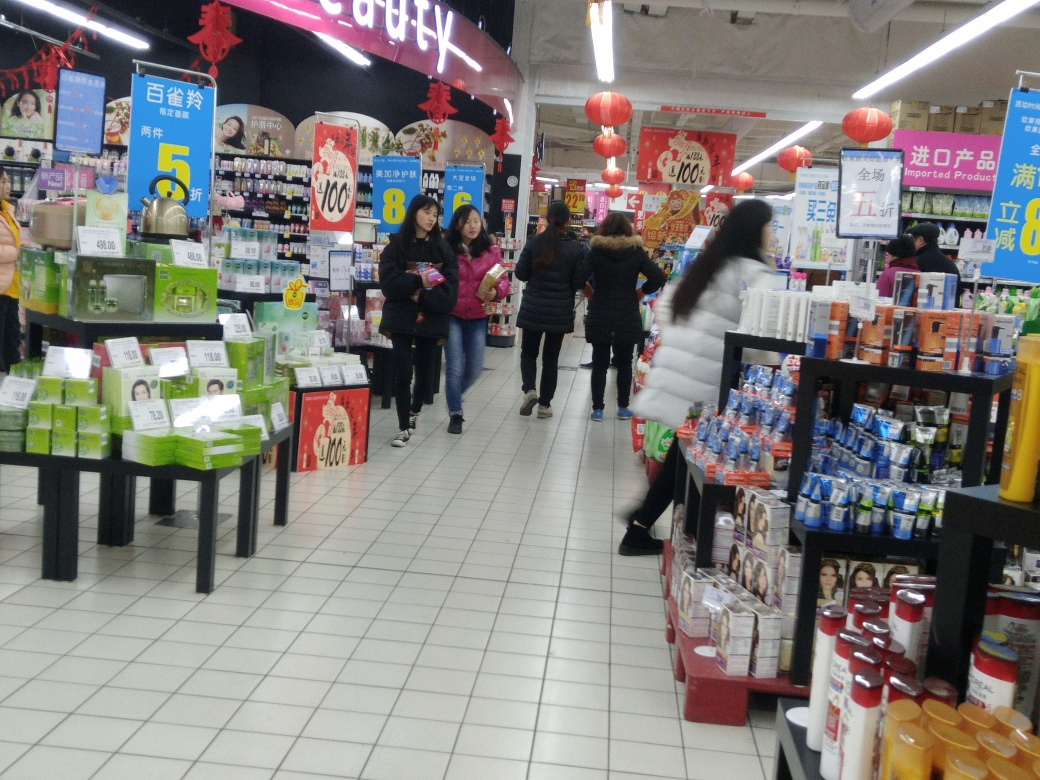What does the image tell us about the shopping behavior of people in the picture? The shoppers appear to be calmly perusing the items, with no overt signs of rushing or panic buying. This behavior indicates a regular shopping day rather than an event-driven rush, like Black Friday sales. Individuals are scattered throughout the aisles, each focused on their own shopping needs, which suggests an orderly retail environment. 